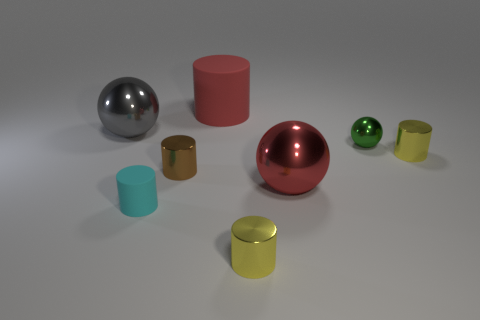There is a large metallic ball on the left side of the matte object to the right of the cyan matte cylinder; how many cyan rubber cylinders are to the right of it?
Your answer should be compact. 1. How many large objects are right of the small cyan rubber object?
Your answer should be very brief. 2. There is a cylinder behind the sphere that is on the left side of the big matte cylinder; what is its color?
Offer a very short reply. Red. What number of other objects are there of the same material as the gray object?
Offer a very short reply. 5. Is the number of red metallic things on the left side of the red shiny sphere the same as the number of tiny cyan matte balls?
Give a very brief answer. Yes. The cylinder that is behind the yellow metal thing to the right of the yellow metallic thing to the left of the big red ball is made of what material?
Your answer should be compact. Rubber. What color is the sphere left of the tiny brown metal thing?
Provide a short and direct response. Gray. Are there any other things that have the same shape as the large matte thing?
Provide a succinct answer. Yes. There is a matte object that is behind the cylinder that is on the right side of the tiny green ball; what size is it?
Ensure brevity in your answer.  Large. Are there the same number of tiny metallic objects behind the brown cylinder and small yellow metal things that are on the left side of the green sphere?
Offer a terse response. No. 